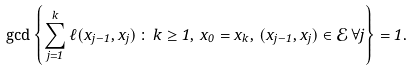Convert formula to latex. <formula><loc_0><loc_0><loc_500><loc_500>\gcd \left \{ \sum _ { j = 1 } ^ { k } \ell ( x _ { j - 1 } , x _ { j } ) \, \colon \, k \geq 1 , \, x _ { 0 } = x _ { k } , \, ( x _ { j - 1 } , x _ { j } ) \in \mathcal { E } \, \forall j \right \} = 1 .</formula> 